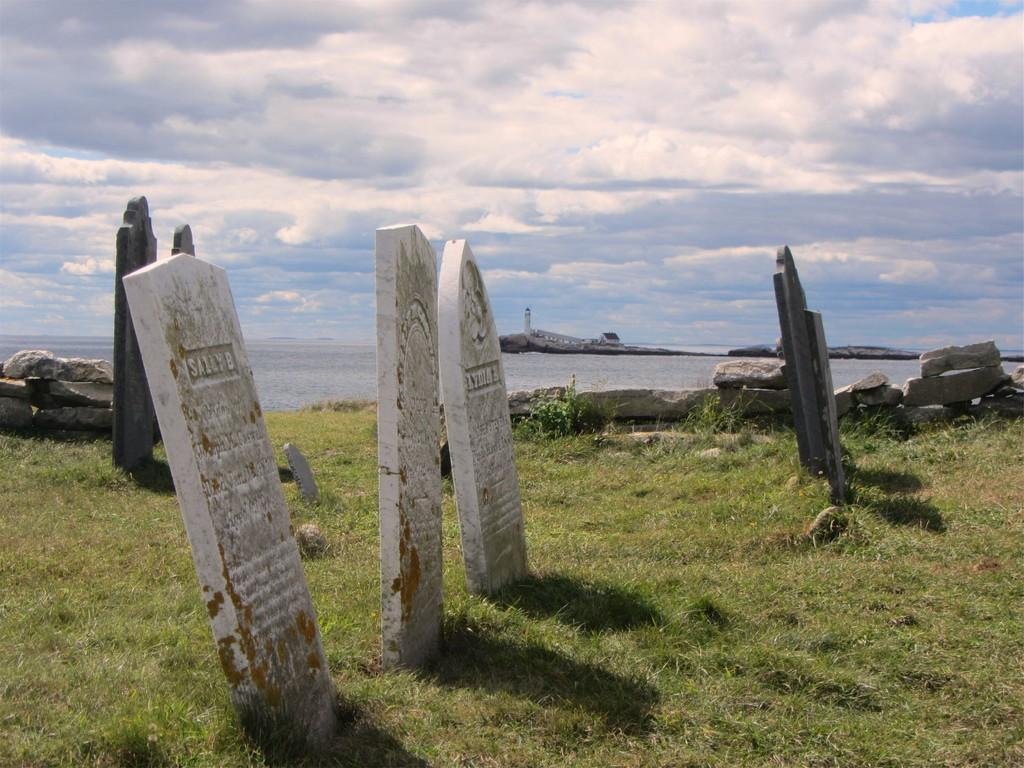What type of structures can be seen in the image? There are headstones in the image. What natural elements are present in the image? There are rocks, grass, and water visible in the image. What can be seen in the background of the image? There is a tower, a house, and the sky visible in the background of the image. What is the condition of the sky in the image? The sky is visible in the background of the image, and clouds are present. Can you tell me how many girls are jumping in the image? There are no girls or jumping depicted in the image; it features headstones, rocks, grass, water, a tower, a house, and the sky with clouds. What type of metal is used to make the headstones in the image? The type of metal used to make the headstones is not mentioned in the image, and there is no indication of metal being used in their construction. 